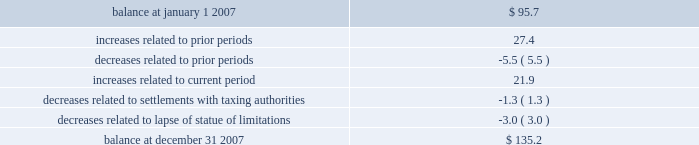In september 2007 , we reached a settlement with the united states department of justice in an ongoing investigation into financial relationships between major orthopaedic manufacturers and consulting orthopaedic surgeons .
Under the terms of the settlement , we paid a civil settlement amount of $ 169.5 million and we recorded an expense in that amount .
No tax benefit has been recorded related to the settlement expense due to the uncertainty as to the tax treatment .
We intend to pursue resolution of this uncertainty with taxing authorities , but are unable to ascertain the outcome or timing for such resolution at this time .
For more information regarding the settlement , see note 15 .
In june 2006 , the financial accounting standards board ( fasb ) issued interpretation no .
48 , accounting for uncertainty in income taxes 2013 an interpretation of fasb statement no .
109 , accounting for income taxes ( fin 48 ) .
Fin 48 addresses the determination of whether tax benefits claimed or expected to be claimed on a tax return should be recorded in the financial statements .
Under fin 48 , we may recognize the tax benefit from an uncertain tax position only if it is more likely than not that the tax position will be sustained on examination by the taxing authorities , based on the technical merits of the position .
The tax benefits recognized in the financial statements from such a position should be measured based on the largest benefit that has a greater than fifty percent likelihood of being realized upon ultimate settlement .
Fin 48 also provides guidance on derecognition , classification , interest and penalties on income taxes , accounting in interim periods and requires increased disclosures .
We adopted fin 48 on january 1 , 2007 .
Prior to the adoption of fin 48 we had a long term tax liability for expected settlement of various federal , state and foreign income tax liabilities that was reflected net of the corollary tax impact of these expected settlements of $ 102.1 million , as well as a separate accrued interest liability of $ 1.7 million .
As a result of the adoption of fin 48 , we are required to present the different components of such liability on a gross basis versus the historical net presentation .
The adoption resulted in the financial statement liability for unrecognized tax benefits decreasing by $ 6.4 million as of january 1 , 2007 .
The adoption resulted in this decrease in the liability as well as a reduction to retained earnings of $ 4.8 million , a reduction in goodwill of $ 61.4 million , the establishment of a tax receivable of $ 58.2 million , which was recorded in other current and non-current assets on our consolidated balance sheet , and an increase in an interest/penalty payable of $ 7.9 million , all as of january 1 , 2007 .
Therefore , after the adoption of fin 48 , the amount of unrecognized tax benefits is $ 95.7 million as of january 1 , 2007 , of which $ 28.6 million would impact our effective tax rate , if recognized .
The amount of unrecognized tax benefits is $ 135.2 million as of december 31 , 2007 .
Of this amount , $ 41.0 million would impact our effective tax rate , if recognized .
A reconciliation of the beginning and ending amounts of unrecognized tax benefits is as follows ( in millions ) : .
We recognize accrued interest and penalties related to unrecognized tax benefits in income tax expense in the consolidated statements of earnings , which is consistent with the recognition of these items in prior reporting periods .
As of january 1 , 2007 , we recorded a liability of $ 9.6 million for accrued interest and penalties , of which $ 7.5 million would impact our effective tax rate , if recognized .
The amount of this liability is $ 19.6 million as of december 31 , 2007 .
Of this amount , $ 14.7 million would impact our effective tax rate , if recognized .
We expect that the amount of tax liability for unrecognized tax benefits will change in the next twelve months ; however , we do not expect these changes will have a significant impact on our results of operations or financial position .
The u.s .
Federal statute of limitations remains open for the year 2003 and onward with years 2003 and 2004 currently under examination by the irs .
It is reasonably possible that a resolution with the irs for the years 2003 through 2004 will be reached within the next twelve months , but we do not anticipate this would result in any material impact on our financial position .
In addition , for the 1999 tax year of centerpulse , which we acquired in october 2003 , one issue remains in dispute .
The resolution of this issue would not impact our effective tax rate , as it would be recorded as an adjustment to goodwill .
State income tax returns are generally subject to examination for a period of 3 to 5 years after filing of the respective return .
The state impact of any federal changes remains subject to examination by various states for a period of up to one year after formal notification to the states .
We have various state income tax returns in the process of examination , administrative appeals or litigation .
It is reasonably possible that such matters will be resolved in the next twelve months , but we do not anticipate that the resolution of these matters would result in any material impact on our results of operations or financial position .
Foreign jurisdictions have statutes of limitations generally ranging from 3 to 5 years .
Years still open to examination by foreign tax authorities in major jurisdictions include australia ( 2003 onward ) , canada ( 1999 onward ) , france ( 2005 onward ) , germany ( 2005 onward ) , italy ( 2003 onward ) , japan ( 2001 onward ) , puerto rico ( 2005 onward ) , singapore ( 2003 onward ) , switzerland ( 2004 onward ) , and the united kingdom ( 2005 onward ) .
Z i m m e r h o l d i n g s , i n c .
2 0 0 7 f o r m 1 0 - k a n n u a l r e p o r t notes to consolidated financial statements ( continued ) .
What percent of the 2007 balance increase is from prior periods? 
Computations: (27.4 / (135.2 - 95.7))
Answer: 0.69367. In september 2007 , we reached a settlement with the united states department of justice in an ongoing investigation into financial relationships between major orthopaedic manufacturers and consulting orthopaedic surgeons .
Under the terms of the settlement , we paid a civil settlement amount of $ 169.5 million and we recorded an expense in that amount .
No tax benefit has been recorded related to the settlement expense due to the uncertainty as to the tax treatment .
We intend to pursue resolution of this uncertainty with taxing authorities , but are unable to ascertain the outcome or timing for such resolution at this time .
For more information regarding the settlement , see note 15 .
In june 2006 , the financial accounting standards board ( fasb ) issued interpretation no .
48 , accounting for uncertainty in income taxes 2013 an interpretation of fasb statement no .
109 , accounting for income taxes ( fin 48 ) .
Fin 48 addresses the determination of whether tax benefits claimed or expected to be claimed on a tax return should be recorded in the financial statements .
Under fin 48 , we may recognize the tax benefit from an uncertain tax position only if it is more likely than not that the tax position will be sustained on examination by the taxing authorities , based on the technical merits of the position .
The tax benefits recognized in the financial statements from such a position should be measured based on the largest benefit that has a greater than fifty percent likelihood of being realized upon ultimate settlement .
Fin 48 also provides guidance on derecognition , classification , interest and penalties on income taxes , accounting in interim periods and requires increased disclosures .
We adopted fin 48 on january 1 , 2007 .
Prior to the adoption of fin 48 we had a long term tax liability for expected settlement of various federal , state and foreign income tax liabilities that was reflected net of the corollary tax impact of these expected settlements of $ 102.1 million , as well as a separate accrued interest liability of $ 1.7 million .
As a result of the adoption of fin 48 , we are required to present the different components of such liability on a gross basis versus the historical net presentation .
The adoption resulted in the financial statement liability for unrecognized tax benefits decreasing by $ 6.4 million as of january 1 , 2007 .
The adoption resulted in this decrease in the liability as well as a reduction to retained earnings of $ 4.8 million , a reduction in goodwill of $ 61.4 million , the establishment of a tax receivable of $ 58.2 million , which was recorded in other current and non-current assets on our consolidated balance sheet , and an increase in an interest/penalty payable of $ 7.9 million , all as of january 1 , 2007 .
Therefore , after the adoption of fin 48 , the amount of unrecognized tax benefits is $ 95.7 million as of january 1 , 2007 , of which $ 28.6 million would impact our effective tax rate , if recognized .
The amount of unrecognized tax benefits is $ 135.2 million as of december 31 , 2007 .
Of this amount , $ 41.0 million would impact our effective tax rate , if recognized .
A reconciliation of the beginning and ending amounts of unrecognized tax benefits is as follows ( in millions ) : .
We recognize accrued interest and penalties related to unrecognized tax benefits in income tax expense in the consolidated statements of earnings , which is consistent with the recognition of these items in prior reporting periods .
As of january 1 , 2007 , we recorded a liability of $ 9.6 million for accrued interest and penalties , of which $ 7.5 million would impact our effective tax rate , if recognized .
The amount of this liability is $ 19.6 million as of december 31 , 2007 .
Of this amount , $ 14.7 million would impact our effective tax rate , if recognized .
We expect that the amount of tax liability for unrecognized tax benefits will change in the next twelve months ; however , we do not expect these changes will have a significant impact on our results of operations or financial position .
The u.s .
Federal statute of limitations remains open for the year 2003 and onward with years 2003 and 2004 currently under examination by the irs .
It is reasonably possible that a resolution with the irs for the years 2003 through 2004 will be reached within the next twelve months , but we do not anticipate this would result in any material impact on our financial position .
In addition , for the 1999 tax year of centerpulse , which we acquired in october 2003 , one issue remains in dispute .
The resolution of this issue would not impact our effective tax rate , as it would be recorded as an adjustment to goodwill .
State income tax returns are generally subject to examination for a period of 3 to 5 years after filing of the respective return .
The state impact of any federal changes remains subject to examination by various states for a period of up to one year after formal notification to the states .
We have various state income tax returns in the process of examination , administrative appeals or litigation .
It is reasonably possible that such matters will be resolved in the next twelve months , but we do not anticipate that the resolution of these matters would result in any material impact on our results of operations or financial position .
Foreign jurisdictions have statutes of limitations generally ranging from 3 to 5 years .
Years still open to examination by foreign tax authorities in major jurisdictions include australia ( 2003 onward ) , canada ( 1999 onward ) , france ( 2005 onward ) , germany ( 2005 onward ) , italy ( 2003 onward ) , japan ( 2001 onward ) , puerto rico ( 2005 onward ) , singapore ( 2003 onward ) , switzerland ( 2004 onward ) , and the united kingdom ( 2005 onward ) .
Z i m m e r h o l d i n g s , i n c .
2 0 0 7 f o r m 1 0 - k a n n u a l r e p o r t notes to consolidated financial statements ( continued ) .
What percentage of unrecognized tax benefits at the end of 2007 would have an affect on taxes? 
Computations: (41.0 / 135.2)
Answer: 0.30325. 